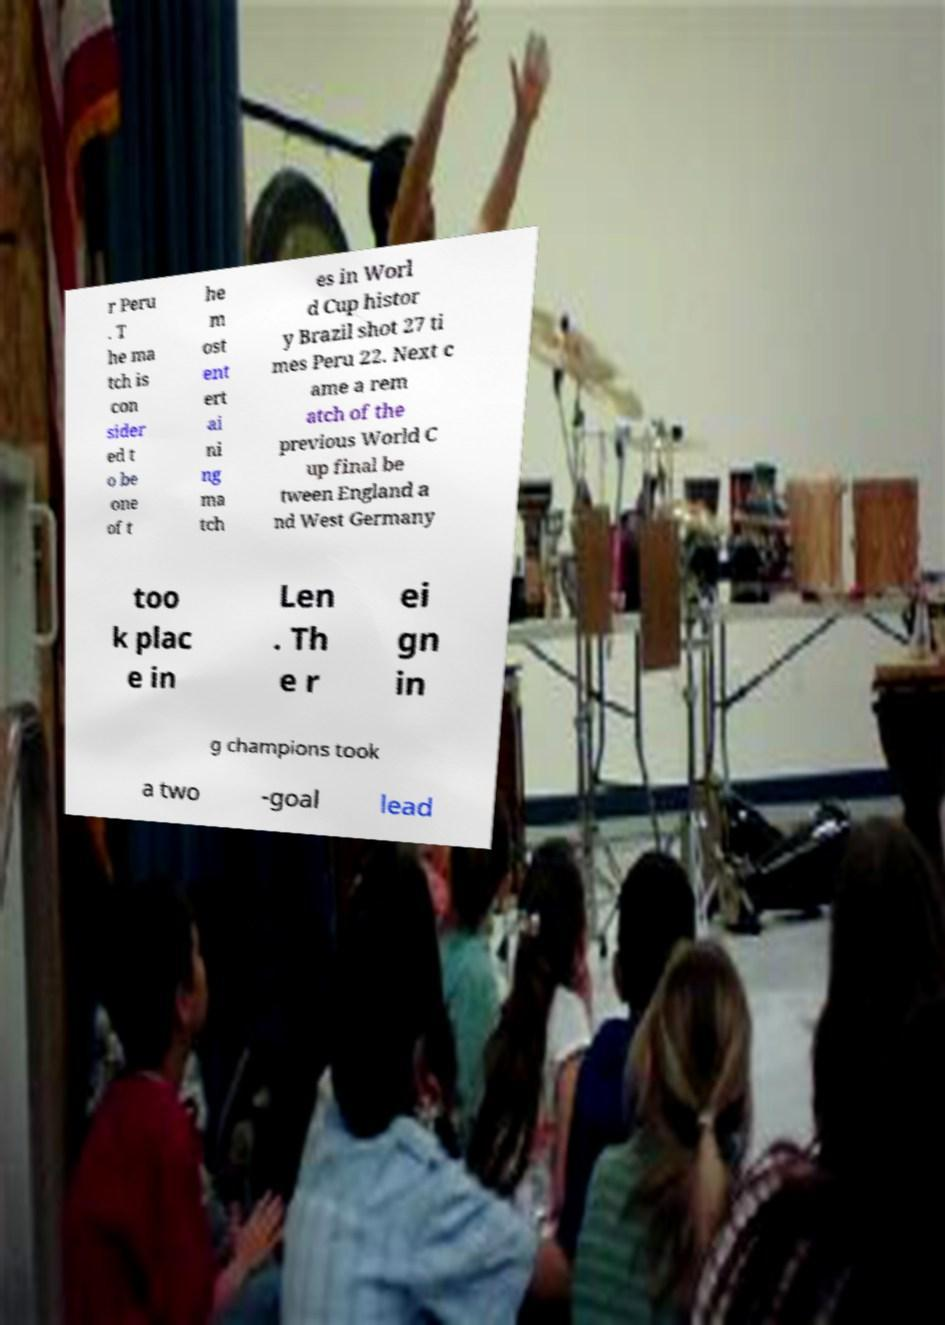Please identify and transcribe the text found in this image. r Peru . T he ma tch is con sider ed t o be one of t he m ost ent ert ai ni ng ma tch es in Worl d Cup histor y Brazil shot 27 ti mes Peru 22. Next c ame a rem atch of the previous World C up final be tween England a nd West Germany too k plac e in Len . Th e r ei gn in g champions took a two -goal lead 